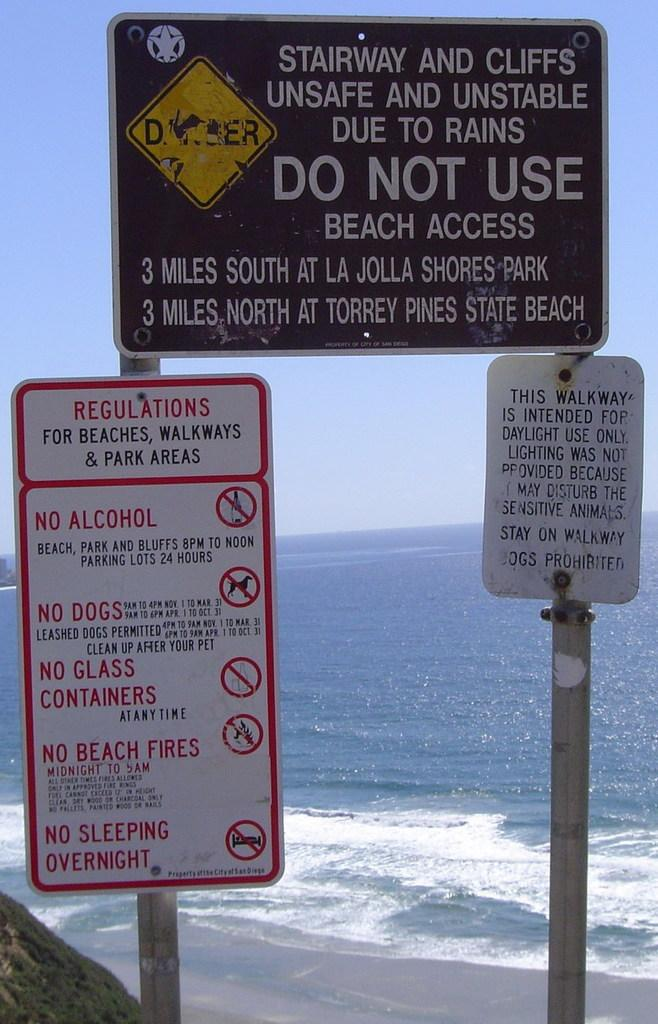<image>
Render a clear and concise summary of the photo. Three differenty sized signs are on poles warning people to not use the stairway and cliffs. 